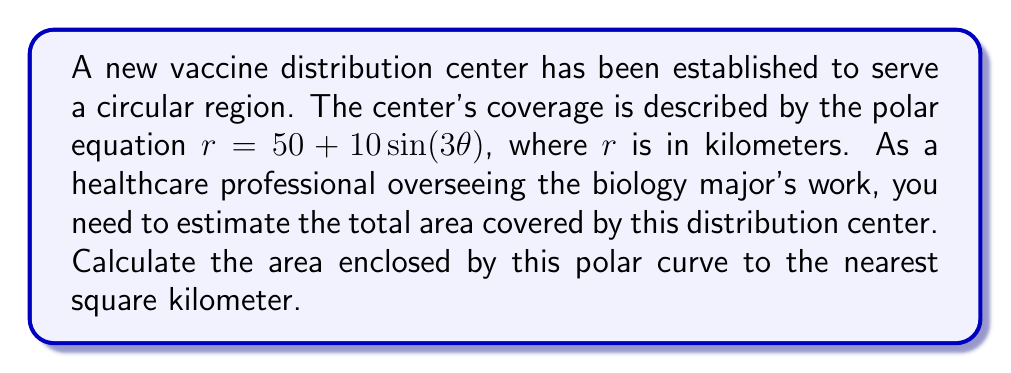Could you help me with this problem? To solve this problem, we'll follow these steps:

1) The area enclosed by a polar curve is given by the formula:

   $$A = \frac{1}{2} \int_{0}^{2\pi} r^2 d\theta$$

2) In this case, $r = 50 + 10\sin(3\theta)$. We need to square this:

   $$r^2 = (50 + 10\sin(3\theta))^2 = 2500 + 1000\sin(3\theta) + 100\sin^2(3\theta)$$

3) Now we can set up our integral:

   $$A = \frac{1}{2} \int_{0}^{2\pi} (2500 + 1000\sin(3\theta) + 100\sin^2(3\theta)) d\theta$$

4) Let's integrate each term separately:

   a) $\int_{0}^{2\pi} 2500 d\theta = 2500\theta \big|_{0}^{2\pi} = 5000\pi$

   b) $\int_{0}^{2\pi} 1000\sin(3\theta) d\theta = -\frac{1000}{3}\cos(3\theta) \big|_{0}^{2\pi} = 0$

   c) For the $\sin^2$ term, we can use the identity $\sin^2x = \frac{1-\cos(2x)}{2}$:
      
      $$\int_{0}^{2\pi} 100\sin^2(3\theta) d\theta = \int_{0}^{2\pi} 50(1-\cos(6\theta)) d\theta$$
      $$= 50\theta - \frac{50}{6}\sin(6\theta) \big|_{0}^{2\pi} = 100\pi$$

5) Adding these results:

   $$A = \frac{1}{2}(5000\pi + 0 + 100\pi) = 2550\pi$$

6) This gives us the area in square kilometers. To round to the nearest square kilometer:

   $$2550\pi \approx 8011.85 \approx 8012 \text{ km}^2$$
Answer: The total area covered by the vaccine distribution center is approximately 8012 square kilometers. 